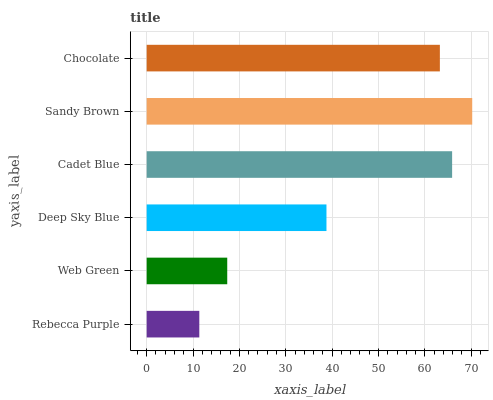Is Rebecca Purple the minimum?
Answer yes or no. Yes. Is Sandy Brown the maximum?
Answer yes or no. Yes. Is Web Green the minimum?
Answer yes or no. No. Is Web Green the maximum?
Answer yes or no. No. Is Web Green greater than Rebecca Purple?
Answer yes or no. Yes. Is Rebecca Purple less than Web Green?
Answer yes or no. Yes. Is Rebecca Purple greater than Web Green?
Answer yes or no. No. Is Web Green less than Rebecca Purple?
Answer yes or no. No. Is Chocolate the high median?
Answer yes or no. Yes. Is Deep Sky Blue the low median?
Answer yes or no. Yes. Is Sandy Brown the high median?
Answer yes or no. No. Is Rebecca Purple the low median?
Answer yes or no. No. 